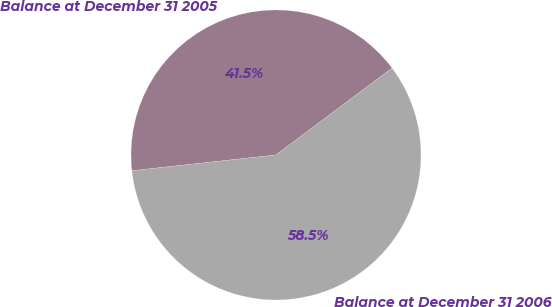<chart> <loc_0><loc_0><loc_500><loc_500><pie_chart><fcel>Balance at December 31 2005<fcel>Balance at December 31 2006<nl><fcel>41.51%<fcel>58.49%<nl></chart> 